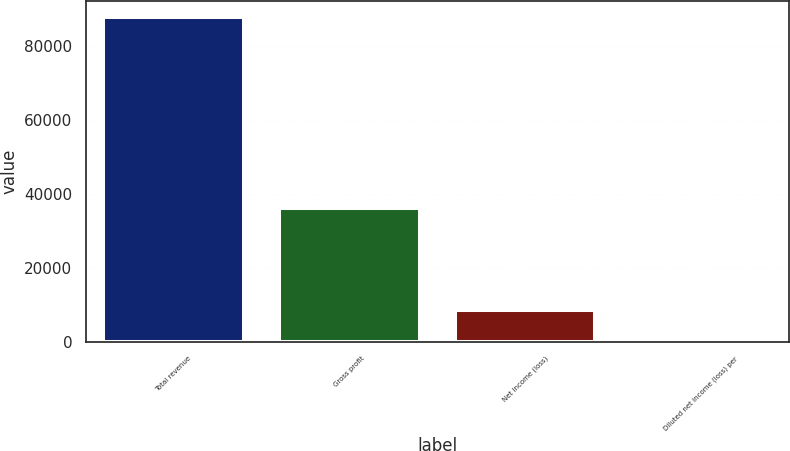Convert chart to OTSL. <chart><loc_0><loc_0><loc_500><loc_500><bar_chart><fcel>Total revenue<fcel>Gross profit<fcel>Net income (loss)<fcel>Diluted net income (loss) per<nl><fcel>87956<fcel>36290<fcel>8795.71<fcel>0.12<nl></chart> 